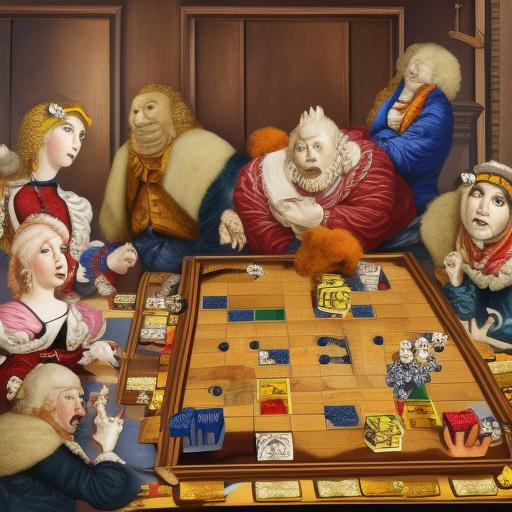What is the mood of the scene depicted in the painting? The painting portrays a scene filled with vibrant social interaction, suggesting a mood of curiosity, concentration, and gentle rivalry. The characters' varied expressions and the bustling activity around the chessboard convey a sense of engagement and entertainment. 